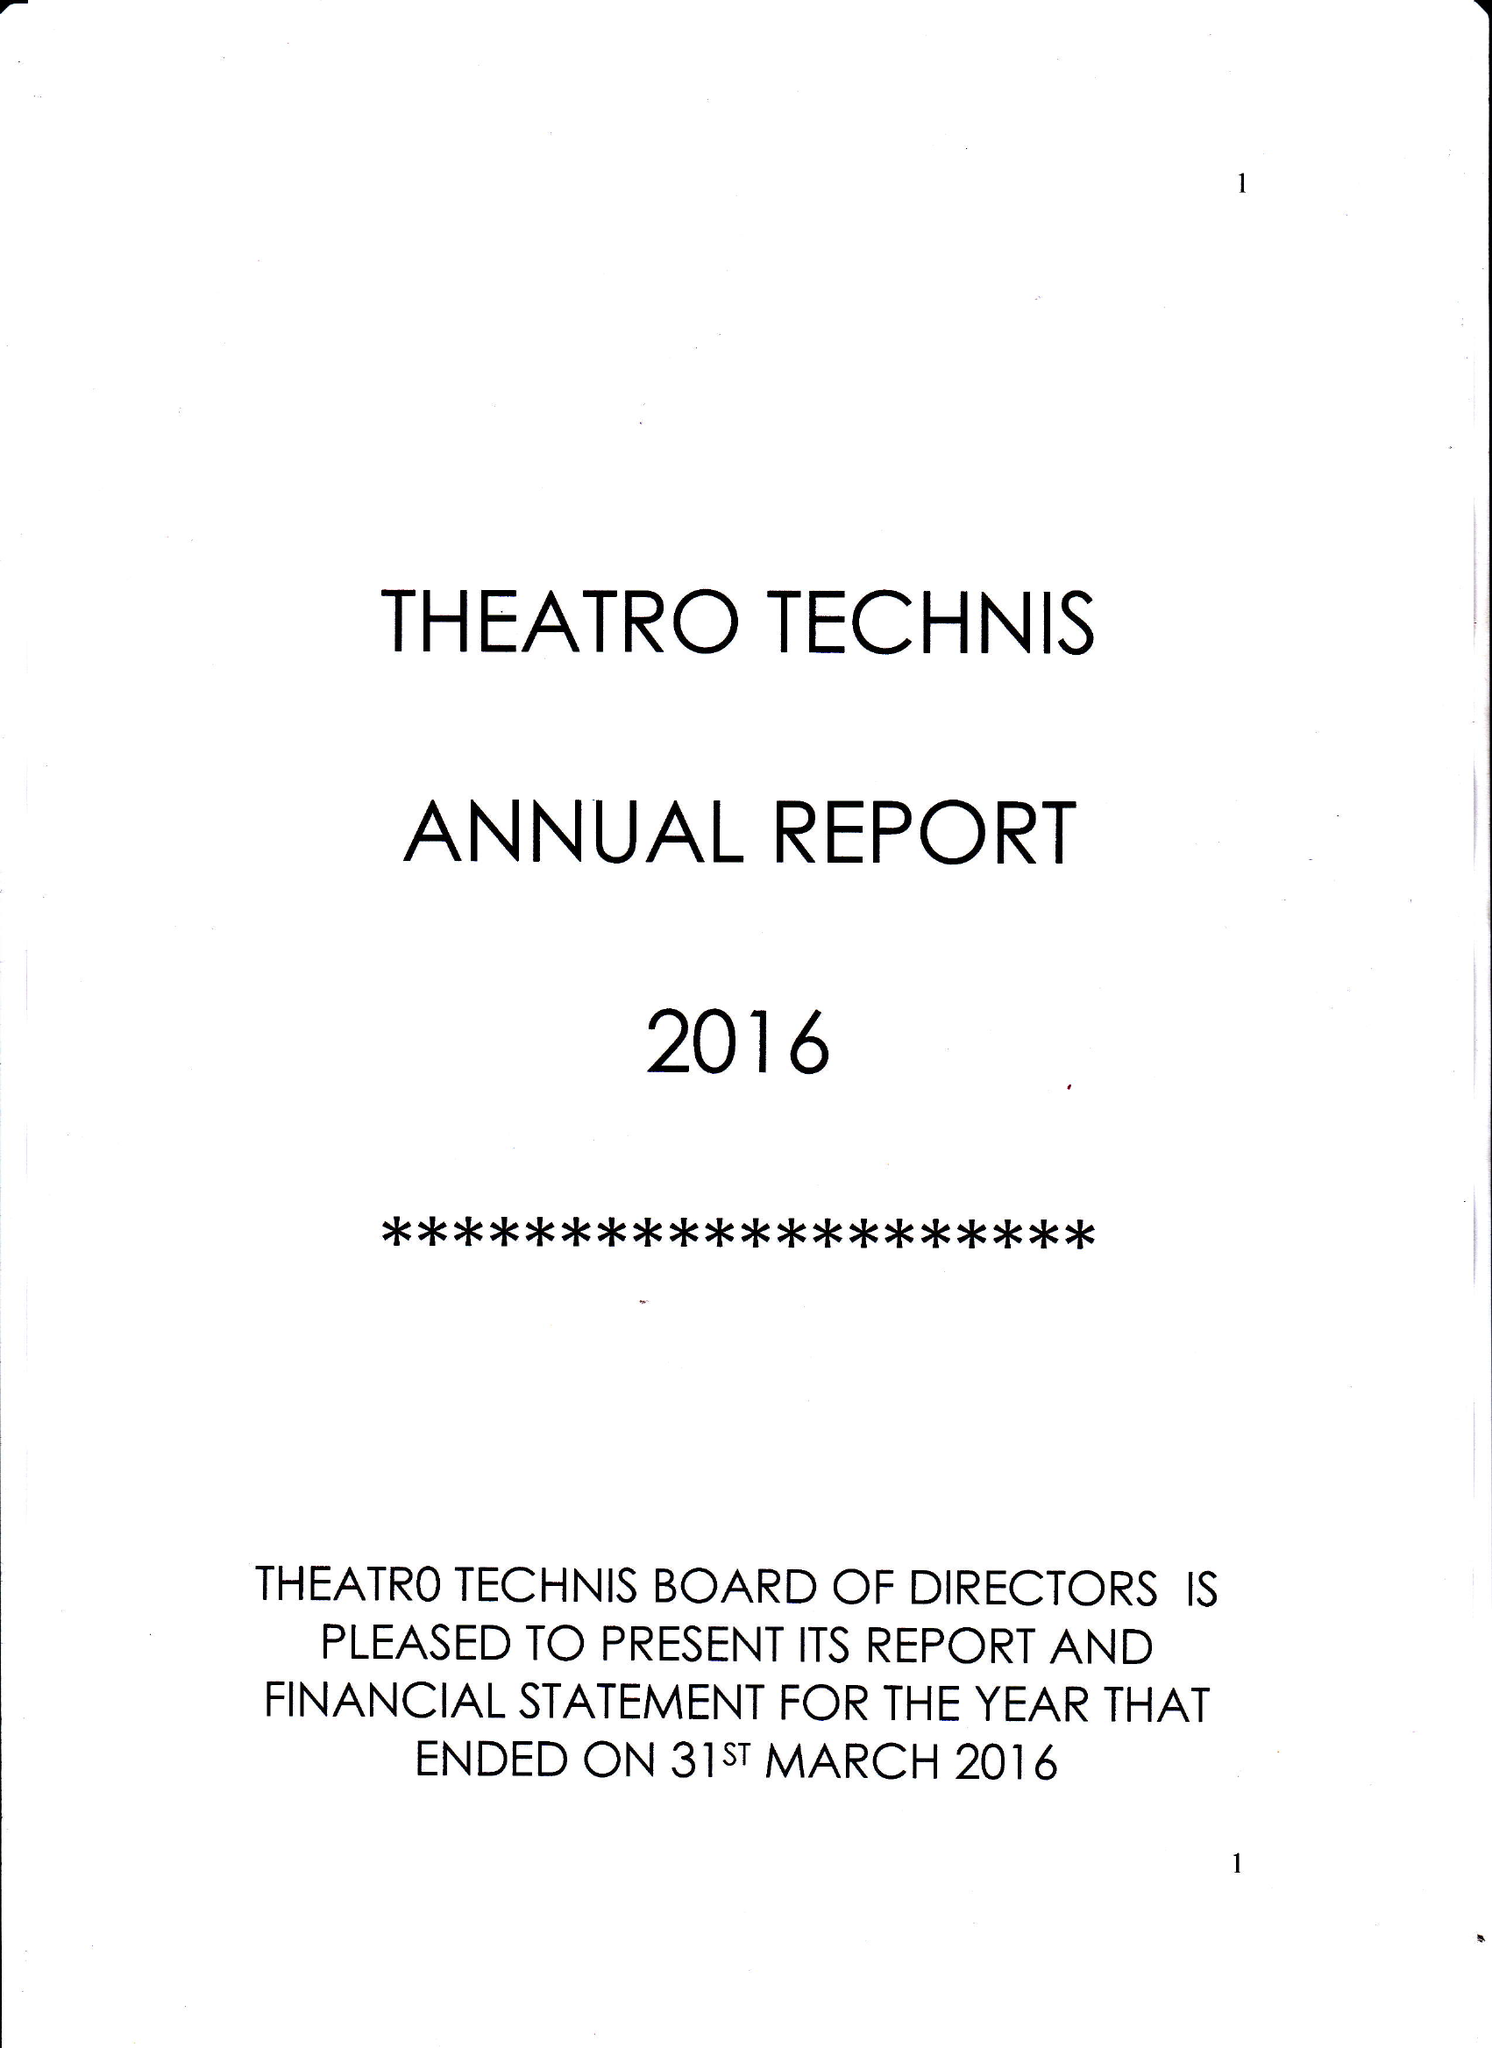What is the value for the address__postcode?
Answer the question using a single word or phrase. NW1 1TT 